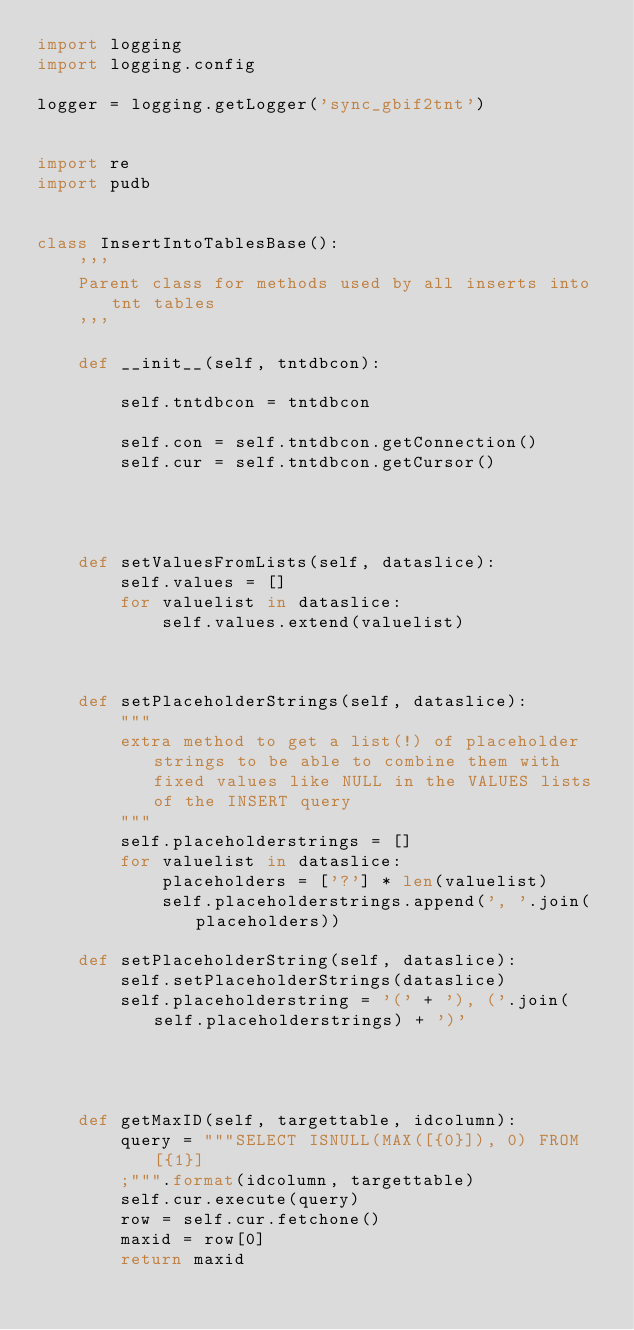Convert code to text. <code><loc_0><loc_0><loc_500><loc_500><_Python_>import logging
import logging.config

logger = logging.getLogger('sync_gbif2tnt')


import re
import pudb


class InsertIntoTablesBase():
	'''
	Parent class for methods used by all inserts into tnt tables
	'''
	
	def __init__(self, tntdbcon):
		
		self.tntdbcon = tntdbcon
		
		self.con = self.tntdbcon.getConnection()
		self.cur = self.tntdbcon.getCursor()
		
	
	
	
	def setValuesFromLists(self, dataslice):
		self.values = []
		for valuelist in dataslice:
			self.values.extend(valuelist)
		
		
		
	def setPlaceholderStrings(self, dataslice):
		"""
		extra method to get a list(!) of placeholder strings to be able to combine them with fixed values like NULL in the VALUES lists of the INSERT query
		"""
		self.placeholderstrings = []
		for valuelist in dataslice:
			placeholders = ['?'] * len(valuelist)
			self.placeholderstrings.append(', '.join(placeholders))
	
	def setPlaceholderString(self, dataslice):
		self.setPlaceholderStrings(dataslice)
		self.placeholderstring = '(' + '), ('.join(self.placeholderstrings) + ')'
	
	
	
	
	def getMaxID(self, targettable, idcolumn):
		query = """SELECT ISNULL(MAX([{0}]), 0) FROM [{1}]
		;""".format(idcolumn, targettable)
		self.cur.execute(query)
		row = self.cur.fetchone()
		maxid = row[0]
		return maxid
	



</code> 